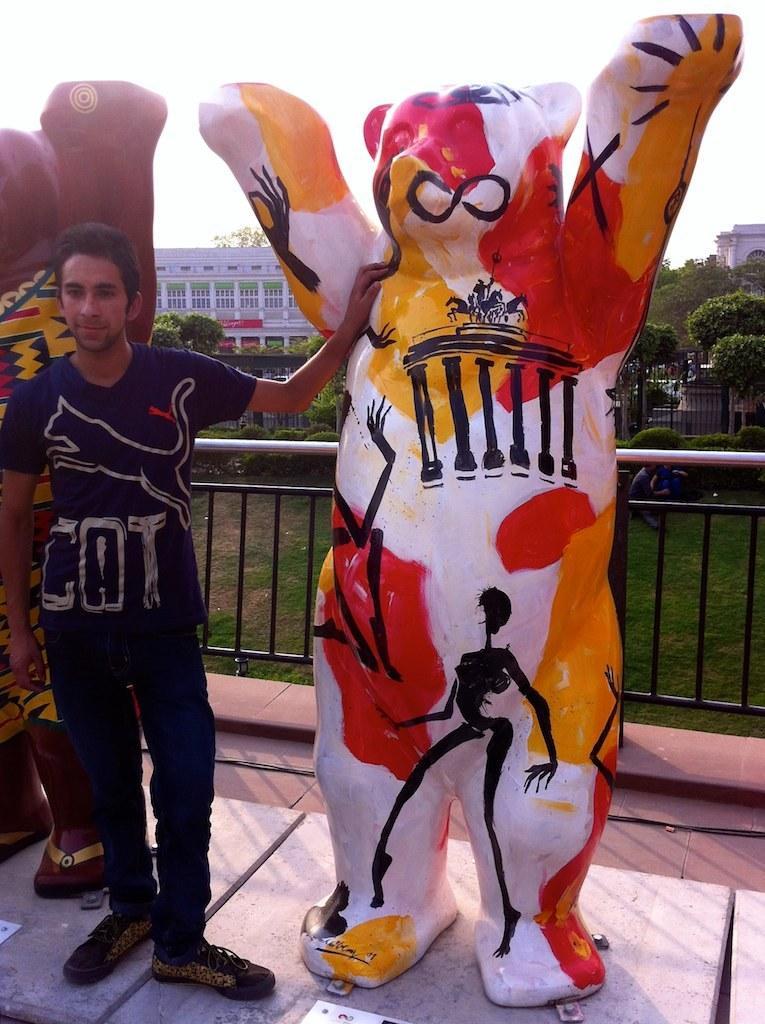How would you summarize this image in a sentence or two? On the right side we had a person standing and touching the statue, black of him a statue is there which is brown in color, and a building. In the middle of the image we have a statue which looks like a animal and which is in red, black, yellow and white in colors. On the left side we have some trees and building. 